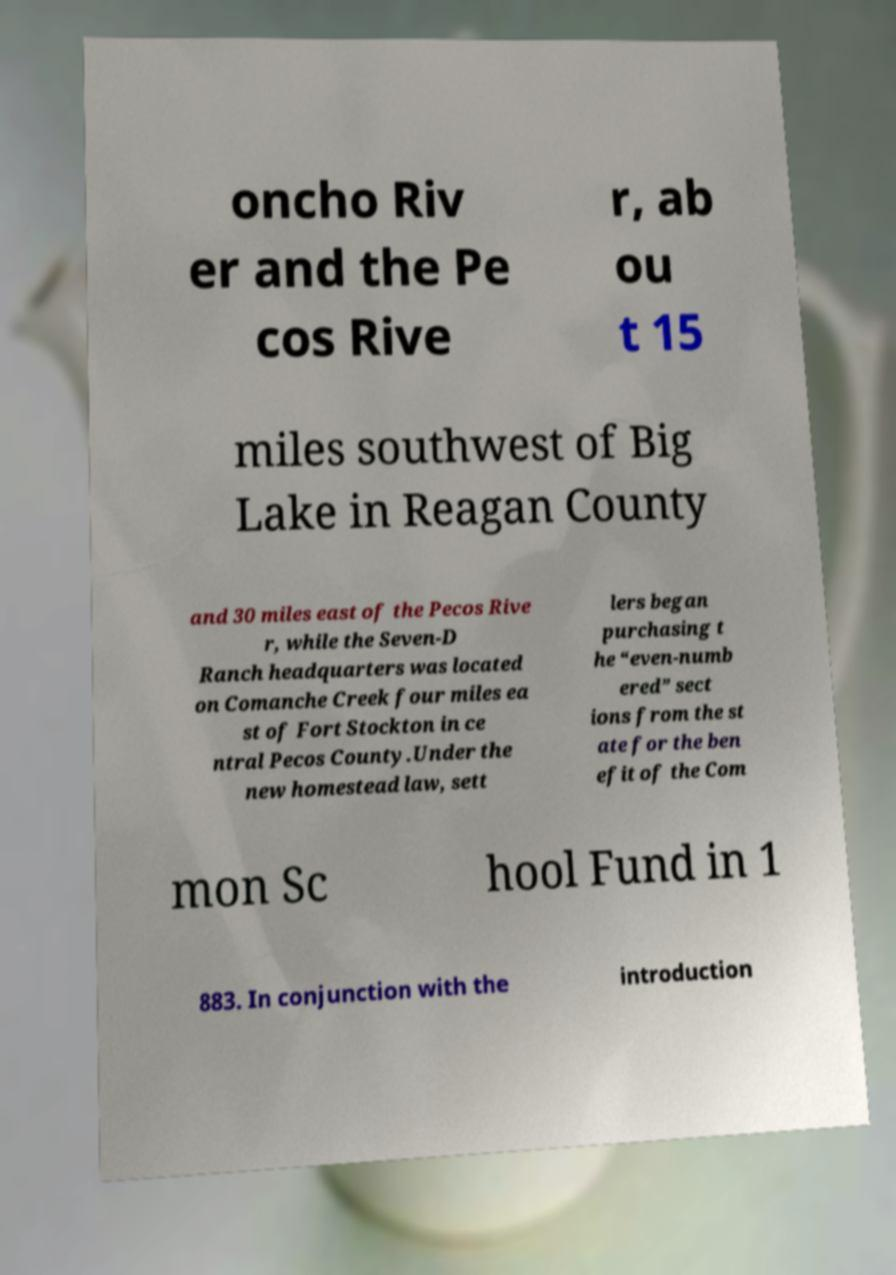Please identify and transcribe the text found in this image. oncho Riv er and the Pe cos Rive r, ab ou t 15 miles southwest of Big Lake in Reagan County and 30 miles east of the Pecos Rive r, while the Seven-D Ranch headquarters was located on Comanche Creek four miles ea st of Fort Stockton in ce ntral Pecos County.Under the new homestead law, sett lers began purchasing t he “even-numb ered” sect ions from the st ate for the ben efit of the Com mon Sc hool Fund in 1 883. In conjunction with the introduction 